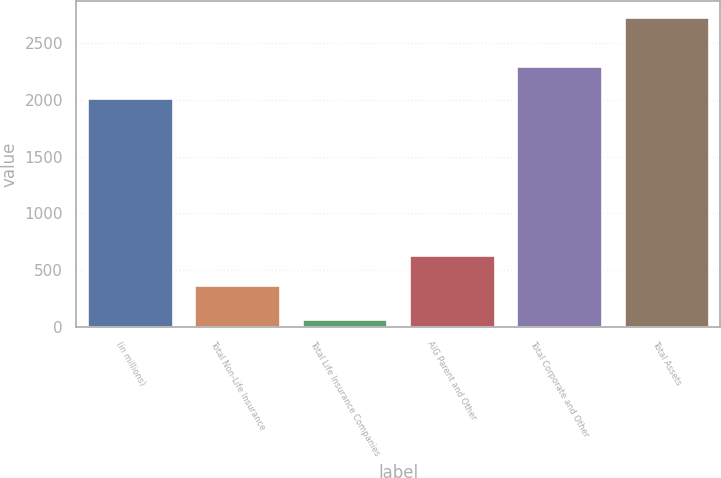Convert chart to OTSL. <chart><loc_0><loc_0><loc_500><loc_500><bar_chart><fcel>(in millions)<fcel>Total Non-Life Insurance<fcel>Total Life Insurance Companies<fcel>AIG Parent and Other<fcel>Total Corporate and Other<fcel>Total Assets<nl><fcel>2013<fcel>370<fcel>66<fcel>636.6<fcel>2296<fcel>2732<nl></chart> 